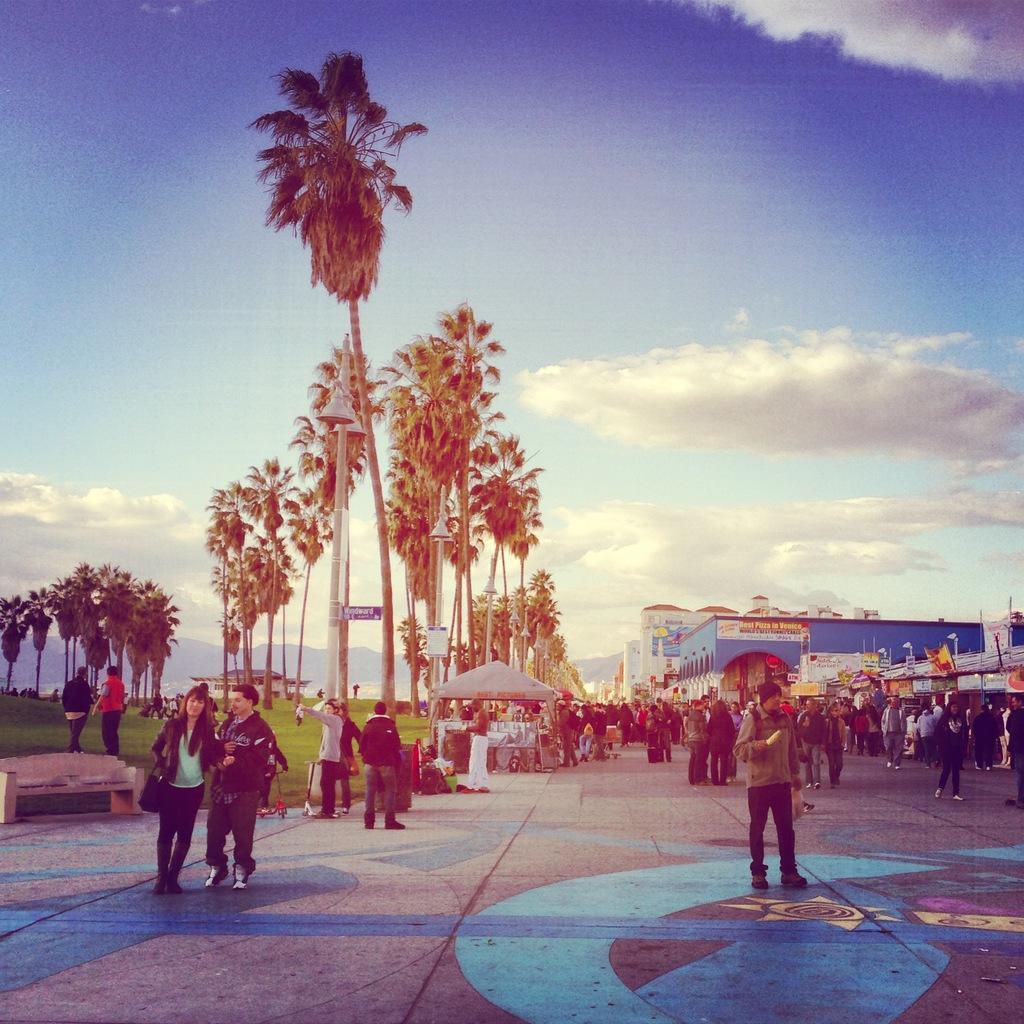How would you summarize this image in a sentence or two? In this image, we can see a crowd. There are some trees and buildings in the middle of the image. There is a bench in the bottom left of the image. In the background of the image, there is a sky. 